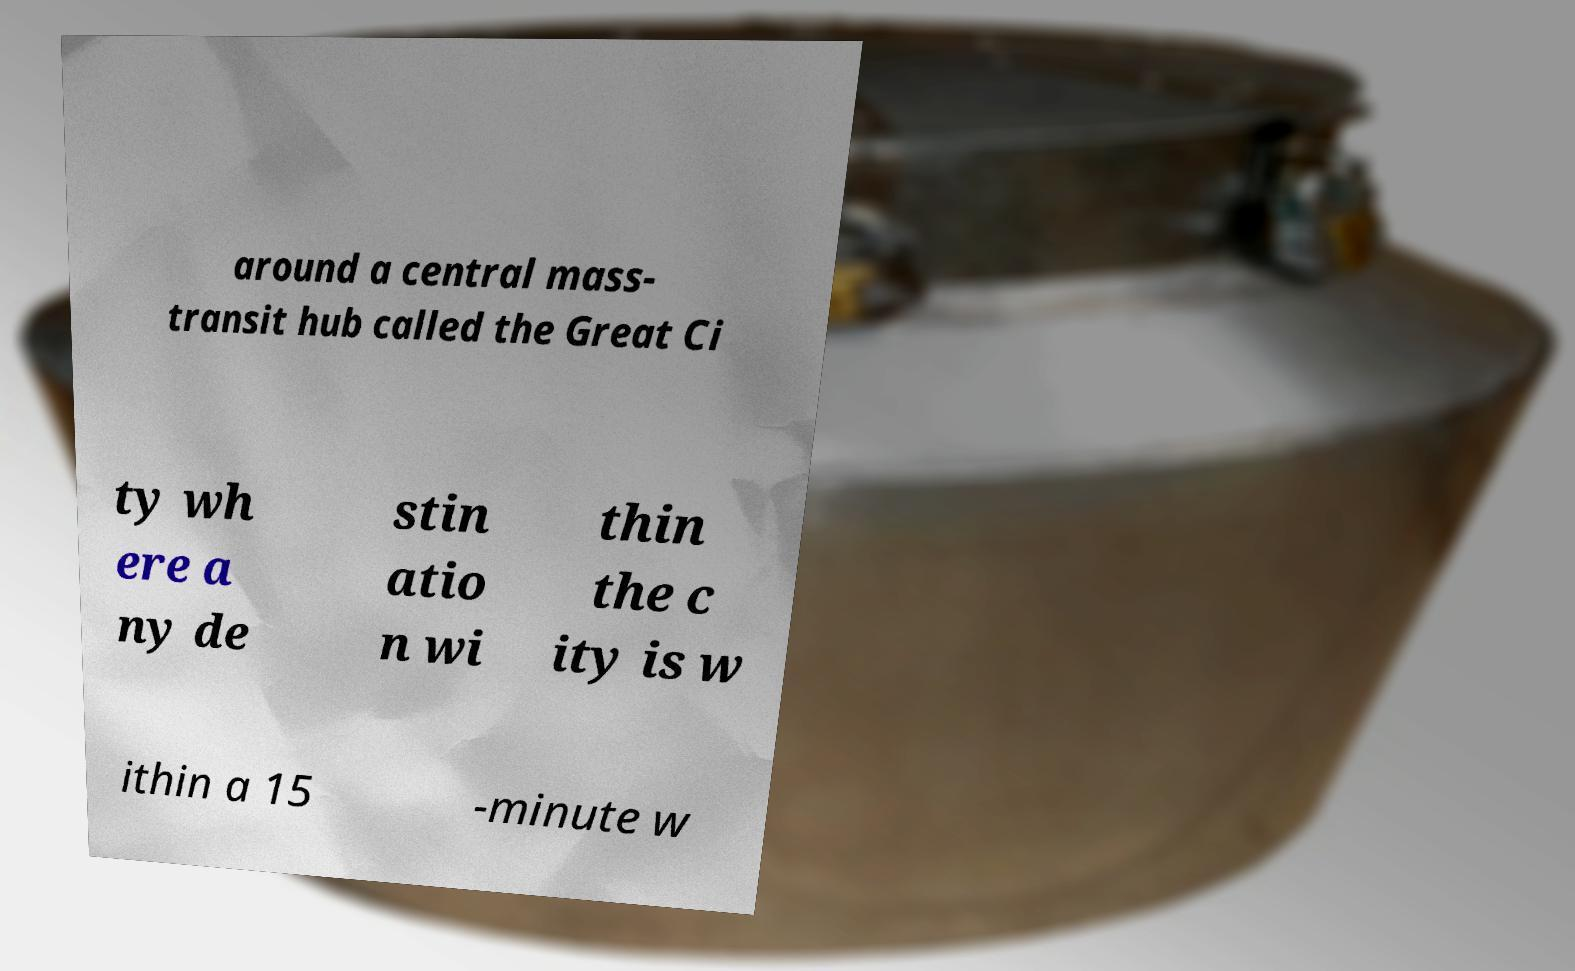Please read and relay the text visible in this image. What does it say? around a central mass- transit hub called the Great Ci ty wh ere a ny de stin atio n wi thin the c ity is w ithin a 15 -minute w 